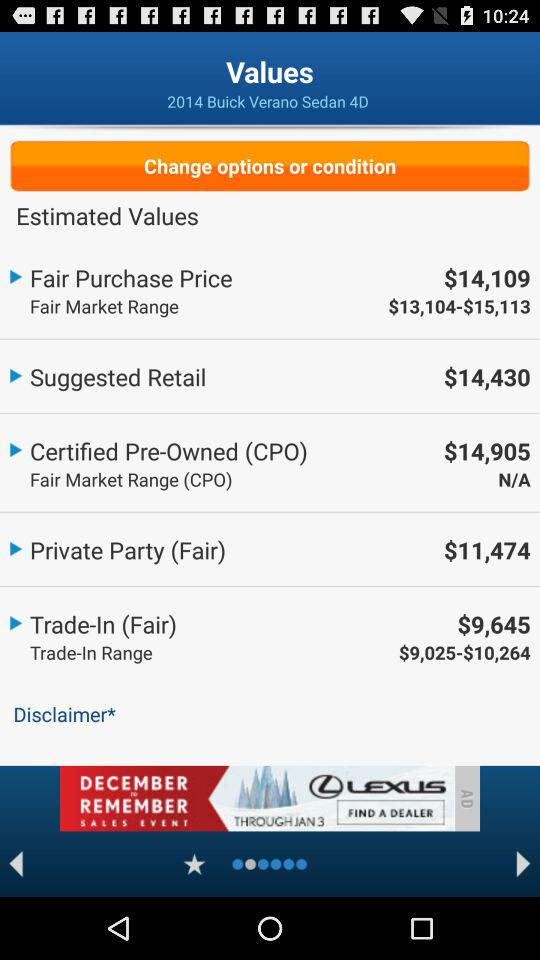What is the suggested retail price? The suggested retail price is $14,430. 